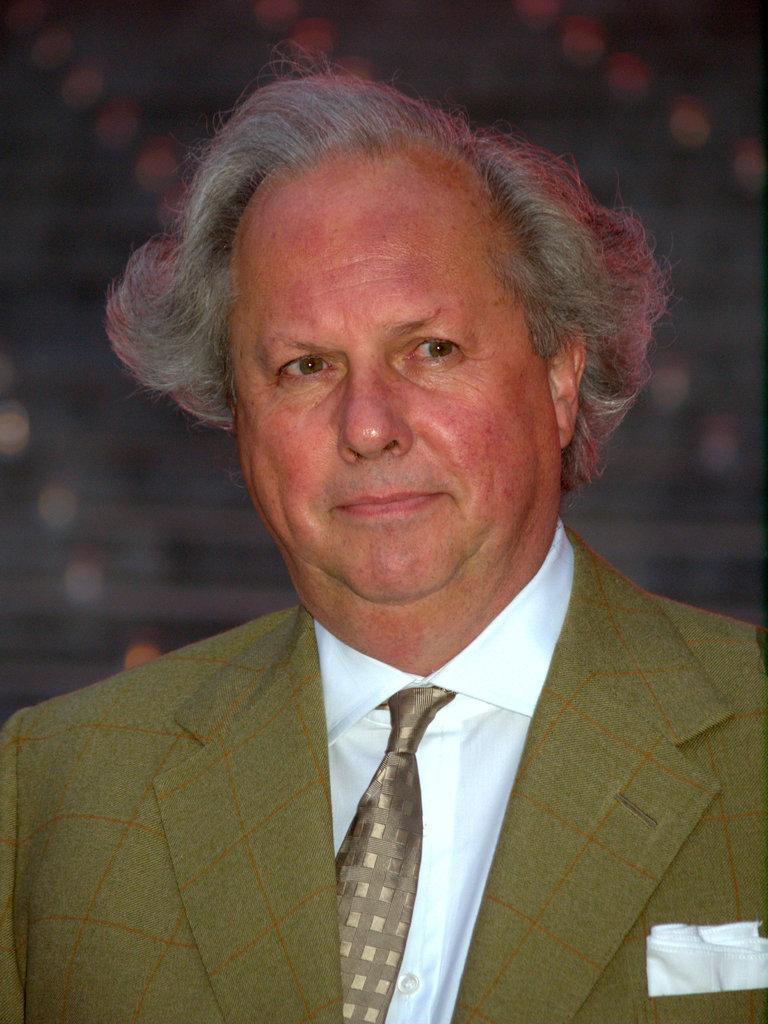Describe this image in one or two sentences. In the image a person is standing and smiling. 